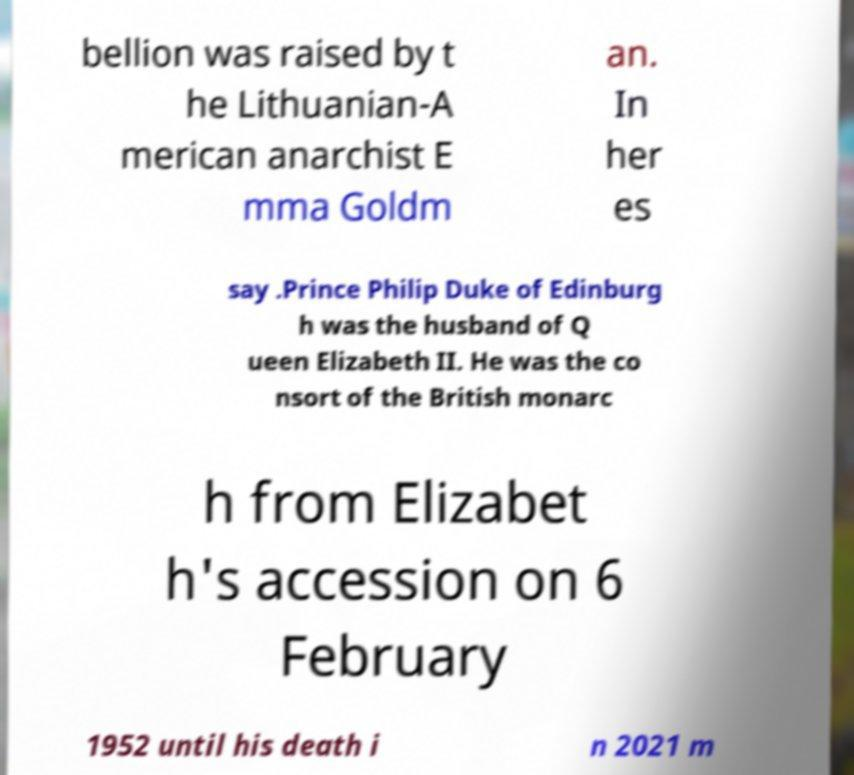I need the written content from this picture converted into text. Can you do that? bellion was raised by t he Lithuanian-A merican anarchist E mma Goldm an. In her es say .Prince Philip Duke of Edinburg h was the husband of Q ueen Elizabeth II. He was the co nsort of the British monarc h from Elizabet h's accession on 6 February 1952 until his death i n 2021 m 